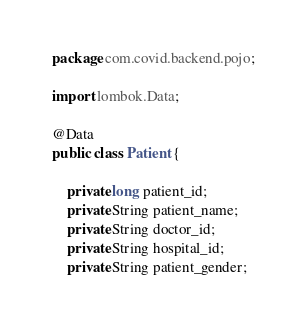<code> <loc_0><loc_0><loc_500><loc_500><_Java_>package com.covid.backend.pojo;

import lombok.Data;

@Data
public class Patient {

    private long patient_id;
    private String patient_name;
    private String doctor_id;
    private String hospital_id;
    private String patient_gender;</code> 